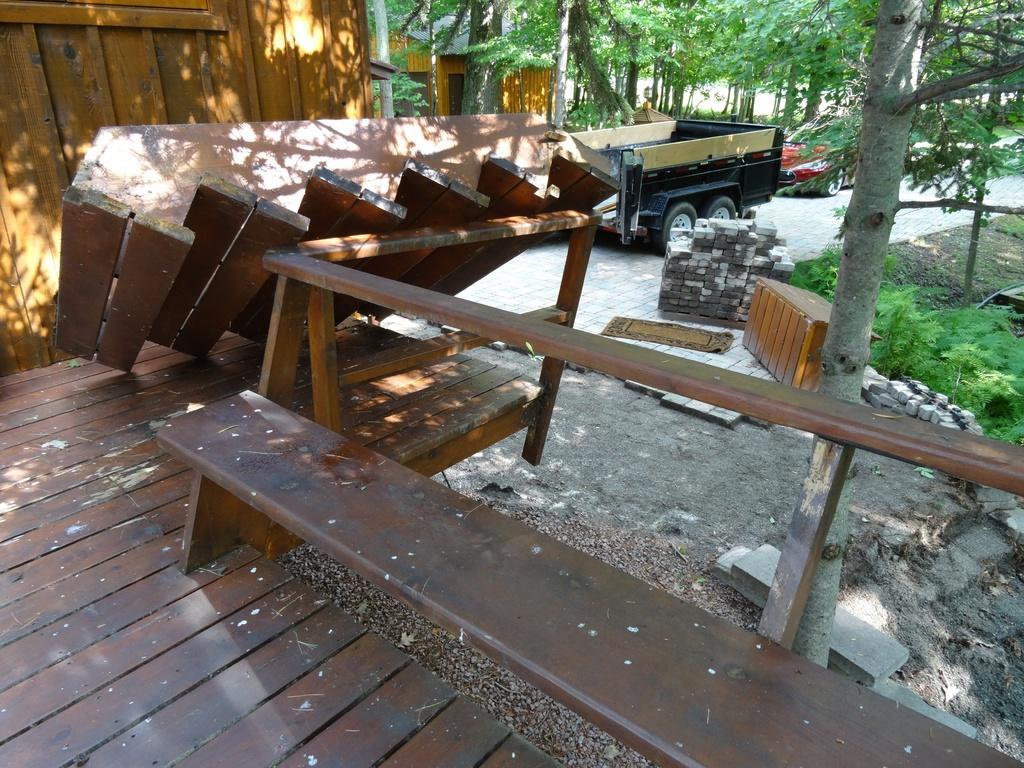Describe this image in one or two sentences. In this image I can see a bench, vehicles and house on the ground. I can also see few trees. 